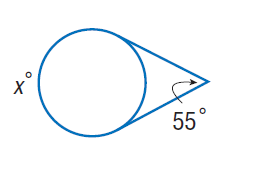Answer the mathemtical geometry problem and directly provide the correct option letter.
Question: Find x.
Choices: A: 55 B: 110 C: 125 D: 235 D 